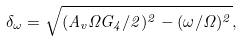<formula> <loc_0><loc_0><loc_500><loc_500>\delta _ { \omega } = \sqrt { ( A _ { v } \Omega G _ { 4 } / 2 ) ^ { 2 } - ( \omega / \Omega ) ^ { 2 } } ,</formula> 